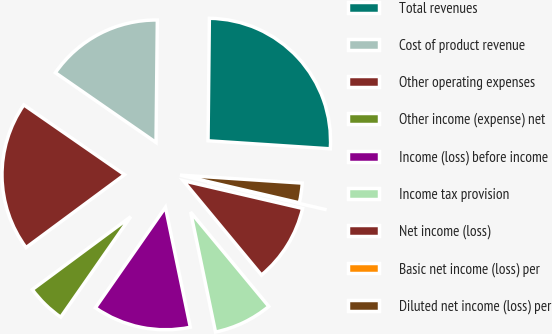<chart> <loc_0><loc_0><loc_500><loc_500><pie_chart><fcel>Total revenues<fcel>Cost of product revenue<fcel>Other operating expenses<fcel>Other income (expense) net<fcel>Income (loss) before income<fcel>Income tax provision<fcel>Net income (loss)<fcel>Basic net income (loss) per<fcel>Diluted net income (loss) per<nl><fcel>25.87%<fcel>15.52%<fcel>19.79%<fcel>5.17%<fcel>12.94%<fcel>7.76%<fcel>10.35%<fcel>0.0%<fcel>2.59%<nl></chart> 